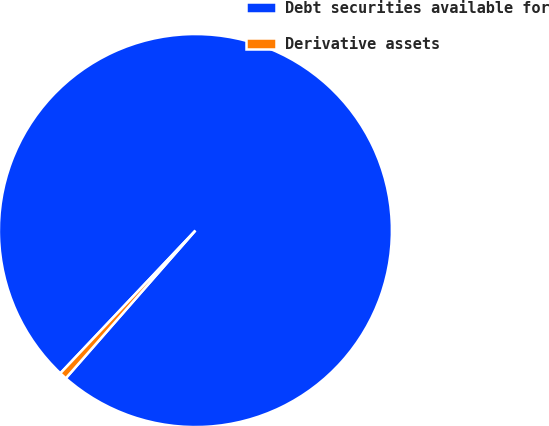Convert chart. <chart><loc_0><loc_0><loc_500><loc_500><pie_chart><fcel>Debt securities available for<fcel>Derivative assets<nl><fcel>99.4%<fcel>0.6%<nl></chart> 